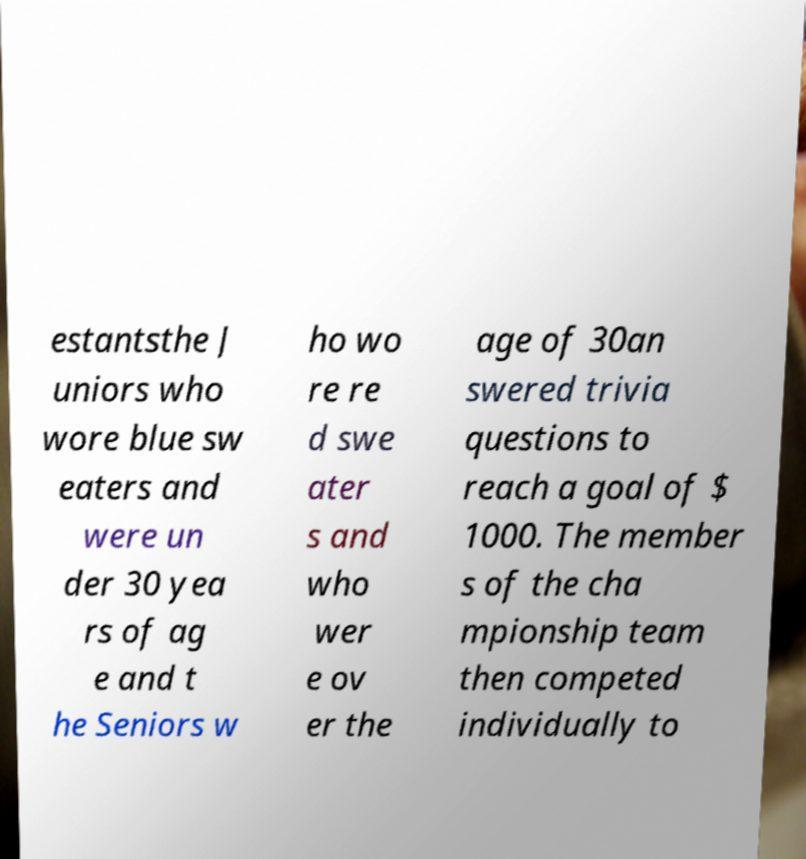There's text embedded in this image that I need extracted. Can you transcribe it verbatim? estantsthe J uniors who wore blue sw eaters and were un der 30 yea rs of ag e and t he Seniors w ho wo re re d swe ater s and who wer e ov er the age of 30an swered trivia questions to reach a goal of $ 1000. The member s of the cha mpionship team then competed individually to 